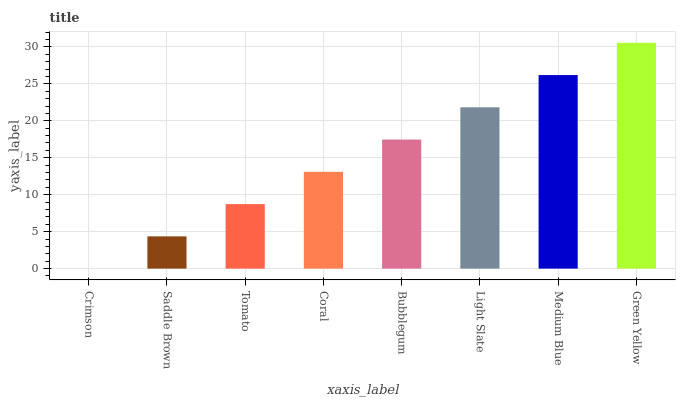Is Crimson the minimum?
Answer yes or no. Yes. Is Green Yellow the maximum?
Answer yes or no. Yes. Is Saddle Brown the minimum?
Answer yes or no. No. Is Saddle Brown the maximum?
Answer yes or no. No. Is Saddle Brown greater than Crimson?
Answer yes or no. Yes. Is Crimson less than Saddle Brown?
Answer yes or no. Yes. Is Crimson greater than Saddle Brown?
Answer yes or no. No. Is Saddle Brown less than Crimson?
Answer yes or no. No. Is Bubblegum the high median?
Answer yes or no. Yes. Is Coral the low median?
Answer yes or no. Yes. Is Coral the high median?
Answer yes or no. No. Is Tomato the low median?
Answer yes or no. No. 